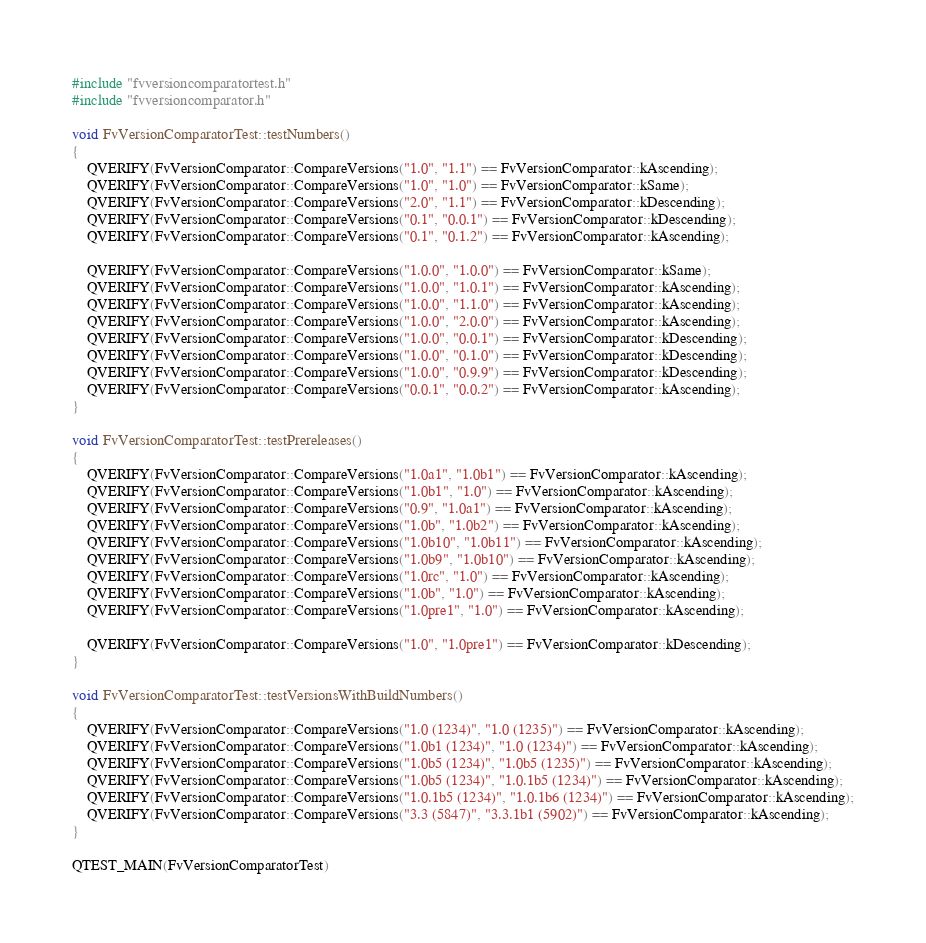<code> <loc_0><loc_0><loc_500><loc_500><_C++_>#include "fvversioncomparatortest.h"
#include "fvversioncomparator.h"

void FvVersionComparatorTest::testNumbers()
{
    QVERIFY(FvVersionComparator::CompareVersions("1.0", "1.1") == FvVersionComparator::kAscending);
    QVERIFY(FvVersionComparator::CompareVersions("1.0", "1.0") == FvVersionComparator::kSame);
    QVERIFY(FvVersionComparator::CompareVersions("2.0", "1.1") == FvVersionComparator::kDescending);
    QVERIFY(FvVersionComparator::CompareVersions("0.1", "0.0.1") == FvVersionComparator::kDescending);
    QVERIFY(FvVersionComparator::CompareVersions("0.1", "0.1.2") == FvVersionComparator::kAscending);

    QVERIFY(FvVersionComparator::CompareVersions("1.0.0", "1.0.0") == FvVersionComparator::kSame);
    QVERIFY(FvVersionComparator::CompareVersions("1.0.0", "1.0.1") == FvVersionComparator::kAscending);
    QVERIFY(FvVersionComparator::CompareVersions("1.0.0", "1.1.0") == FvVersionComparator::kAscending);
    QVERIFY(FvVersionComparator::CompareVersions("1.0.0", "2.0.0") == FvVersionComparator::kAscending);
    QVERIFY(FvVersionComparator::CompareVersions("1.0.0", "0.0.1") == FvVersionComparator::kDescending);
    QVERIFY(FvVersionComparator::CompareVersions("1.0.0", "0.1.0") == FvVersionComparator::kDescending);
    QVERIFY(FvVersionComparator::CompareVersions("1.0.0", "0.9.9") == FvVersionComparator::kDescending);
    QVERIFY(FvVersionComparator::CompareVersions("0.0.1", "0.0.2") == FvVersionComparator::kAscending);
}

void FvVersionComparatorTest::testPrereleases()
{
    QVERIFY(FvVersionComparator::CompareVersions("1.0a1", "1.0b1") == FvVersionComparator::kAscending);
    QVERIFY(FvVersionComparator::CompareVersions("1.0b1", "1.0") == FvVersionComparator::kAscending);
    QVERIFY(FvVersionComparator::CompareVersions("0.9", "1.0a1") == FvVersionComparator::kAscending);
    QVERIFY(FvVersionComparator::CompareVersions("1.0b", "1.0b2") == FvVersionComparator::kAscending);
    QVERIFY(FvVersionComparator::CompareVersions("1.0b10", "1.0b11") == FvVersionComparator::kAscending);
    QVERIFY(FvVersionComparator::CompareVersions("1.0b9", "1.0b10") == FvVersionComparator::kAscending);
    QVERIFY(FvVersionComparator::CompareVersions("1.0rc", "1.0") == FvVersionComparator::kAscending);
    QVERIFY(FvVersionComparator::CompareVersions("1.0b", "1.0") == FvVersionComparator::kAscending);
    QVERIFY(FvVersionComparator::CompareVersions("1.0pre1", "1.0") == FvVersionComparator::kAscending);

    QVERIFY(FvVersionComparator::CompareVersions("1.0", "1.0pre1") == FvVersionComparator::kDescending);
}

void FvVersionComparatorTest::testVersionsWithBuildNumbers()
{
    QVERIFY(FvVersionComparator::CompareVersions("1.0 (1234)", "1.0 (1235)") == FvVersionComparator::kAscending);
    QVERIFY(FvVersionComparator::CompareVersions("1.0b1 (1234)", "1.0 (1234)") == FvVersionComparator::kAscending);
    QVERIFY(FvVersionComparator::CompareVersions("1.0b5 (1234)", "1.0b5 (1235)") == FvVersionComparator::kAscending);
    QVERIFY(FvVersionComparator::CompareVersions("1.0b5 (1234)", "1.0.1b5 (1234)") == FvVersionComparator::kAscending);
    QVERIFY(FvVersionComparator::CompareVersions("1.0.1b5 (1234)", "1.0.1b6 (1234)") == FvVersionComparator::kAscending);
    QVERIFY(FvVersionComparator::CompareVersions("3.3 (5847)", "3.3.1b1 (5902)") == FvVersionComparator::kAscending);
}

QTEST_MAIN(FvVersionComparatorTest)</code> 